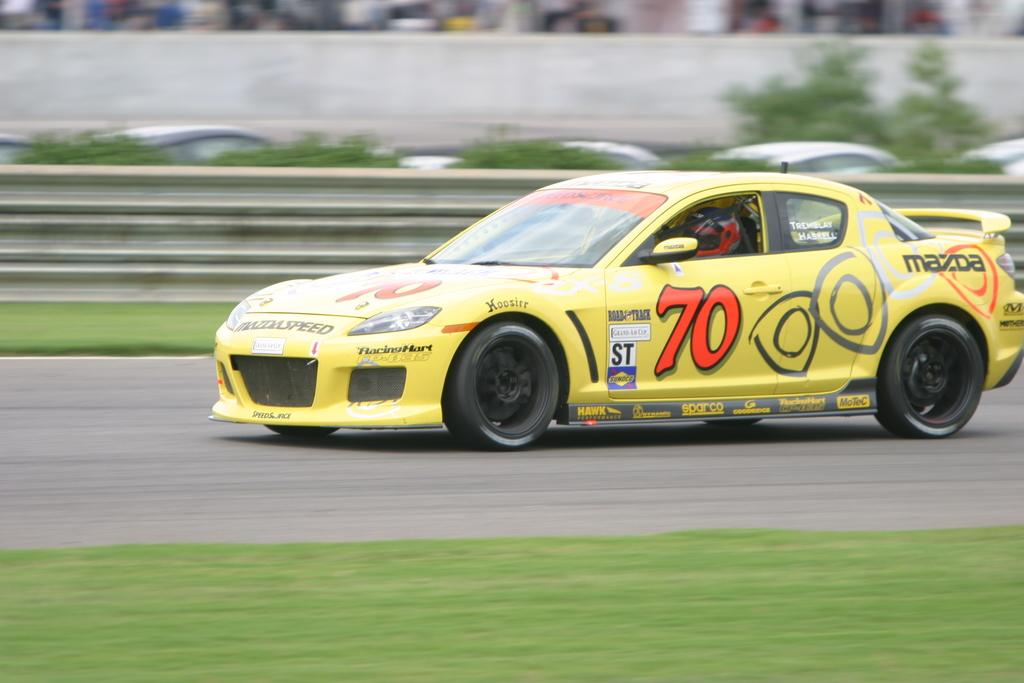What is the main subject in the center of the image? There is a car in the center of the image. Where is the car located? The car is on the road. What can be seen in the background of the image? There are trees in the background of the image. What is visible at the bottom of the image? The ground is visible at the bottom of the image. Is the river flowing in the background of the image? There is no river present in the image; only trees can be seen in the background. 